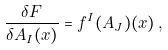<formula> <loc_0><loc_0><loc_500><loc_500>\frac { \delta F } { \delta A _ { I } ( x ) } = f ^ { I } ( A _ { J } ) ( x ) \, ,</formula> 